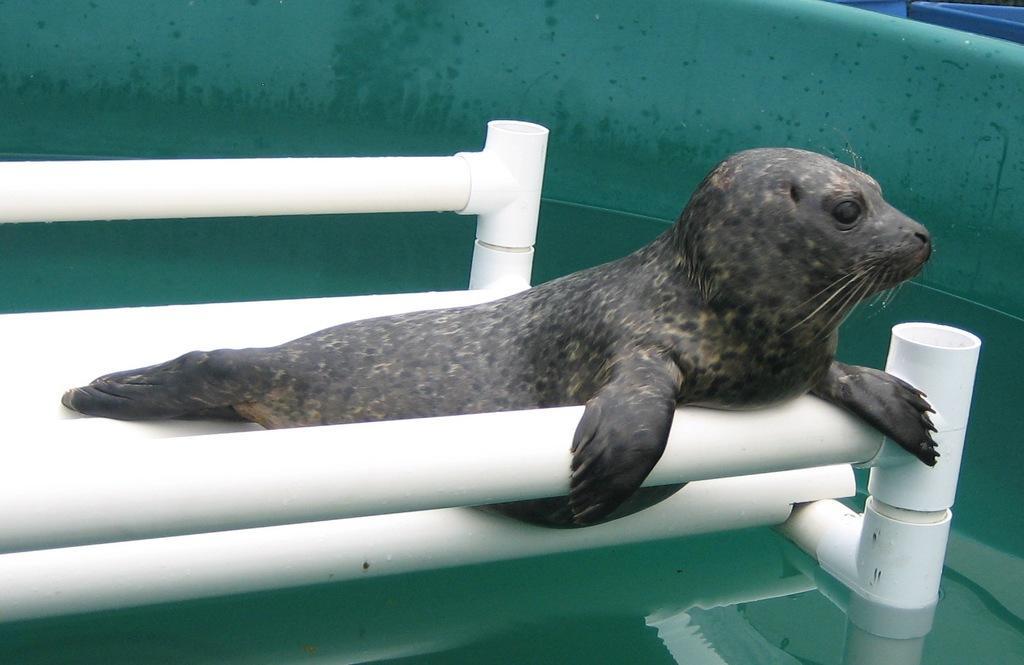Can you describe this image briefly? In this picture we can see a Seal in a tub of water with white pipes. 